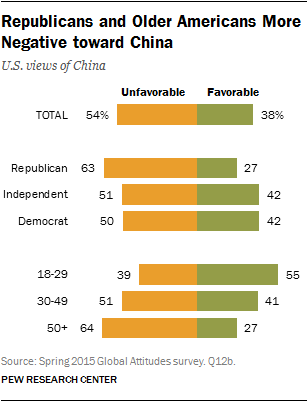Give some essential details in this illustration. The difference between the largest orange bar and the smallest green bar is 37.. 